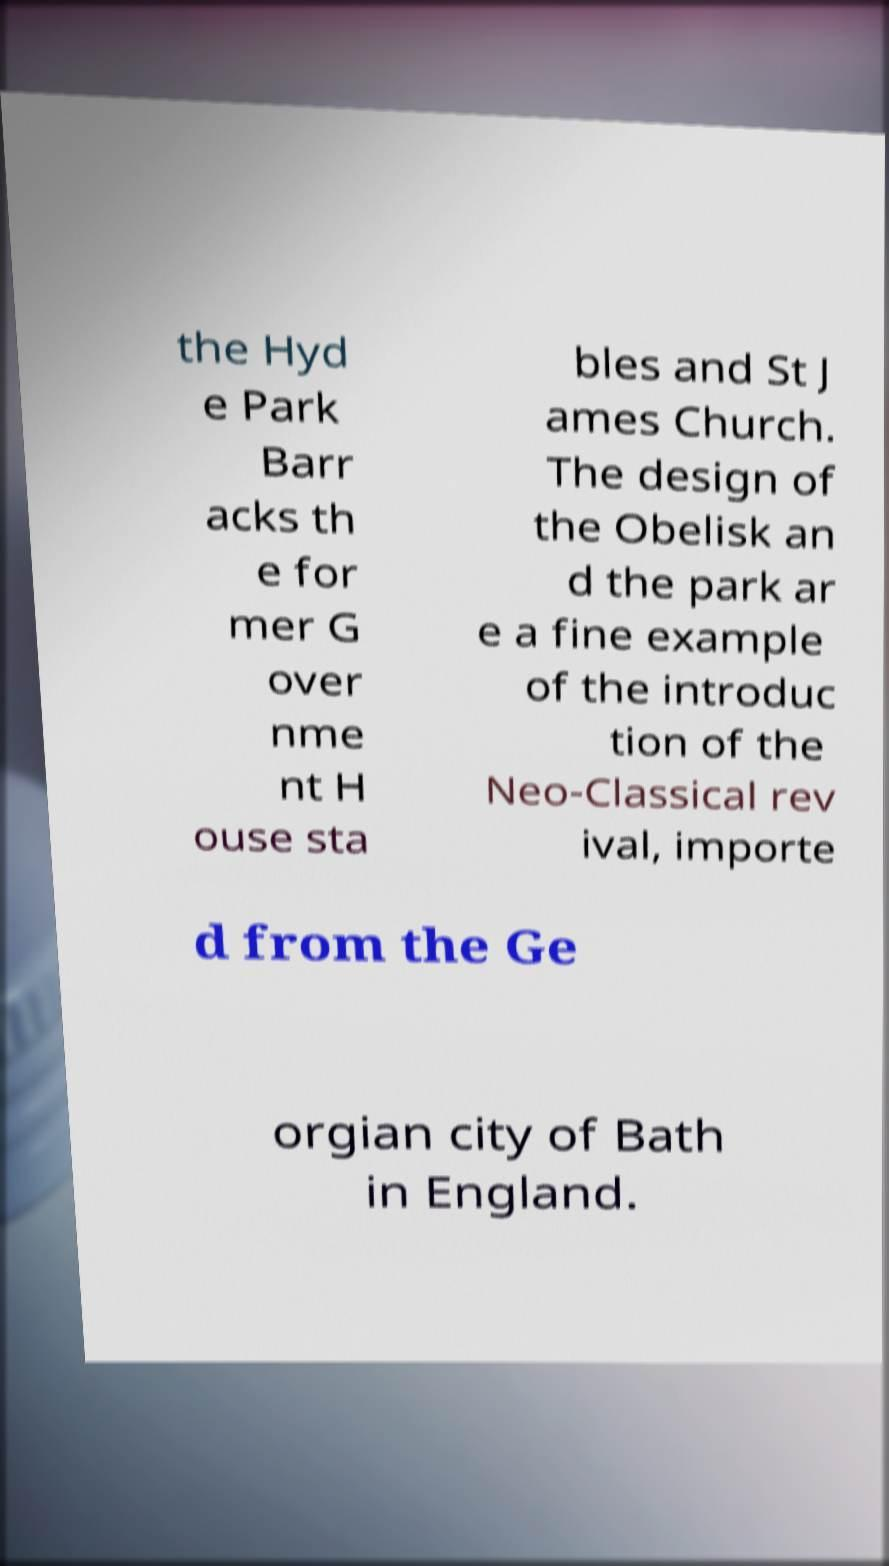Could you assist in decoding the text presented in this image and type it out clearly? the Hyd e Park Barr acks th e for mer G over nme nt H ouse sta bles and St J ames Church. The design of the Obelisk an d the park ar e a fine example of the introduc tion of the Neo-Classical rev ival, importe d from the Ge orgian city of Bath in England. 